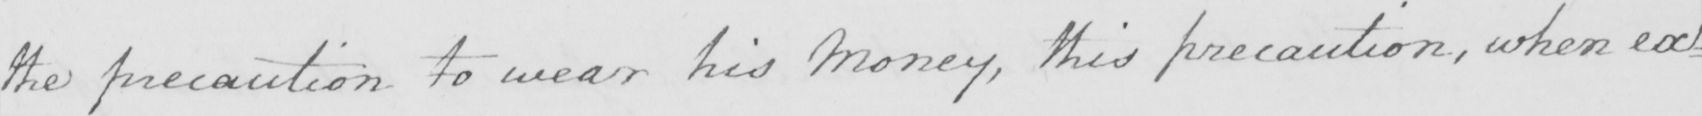Please provide the text content of this handwritten line. the precaution to wear his Money , this precaution , when ex= 